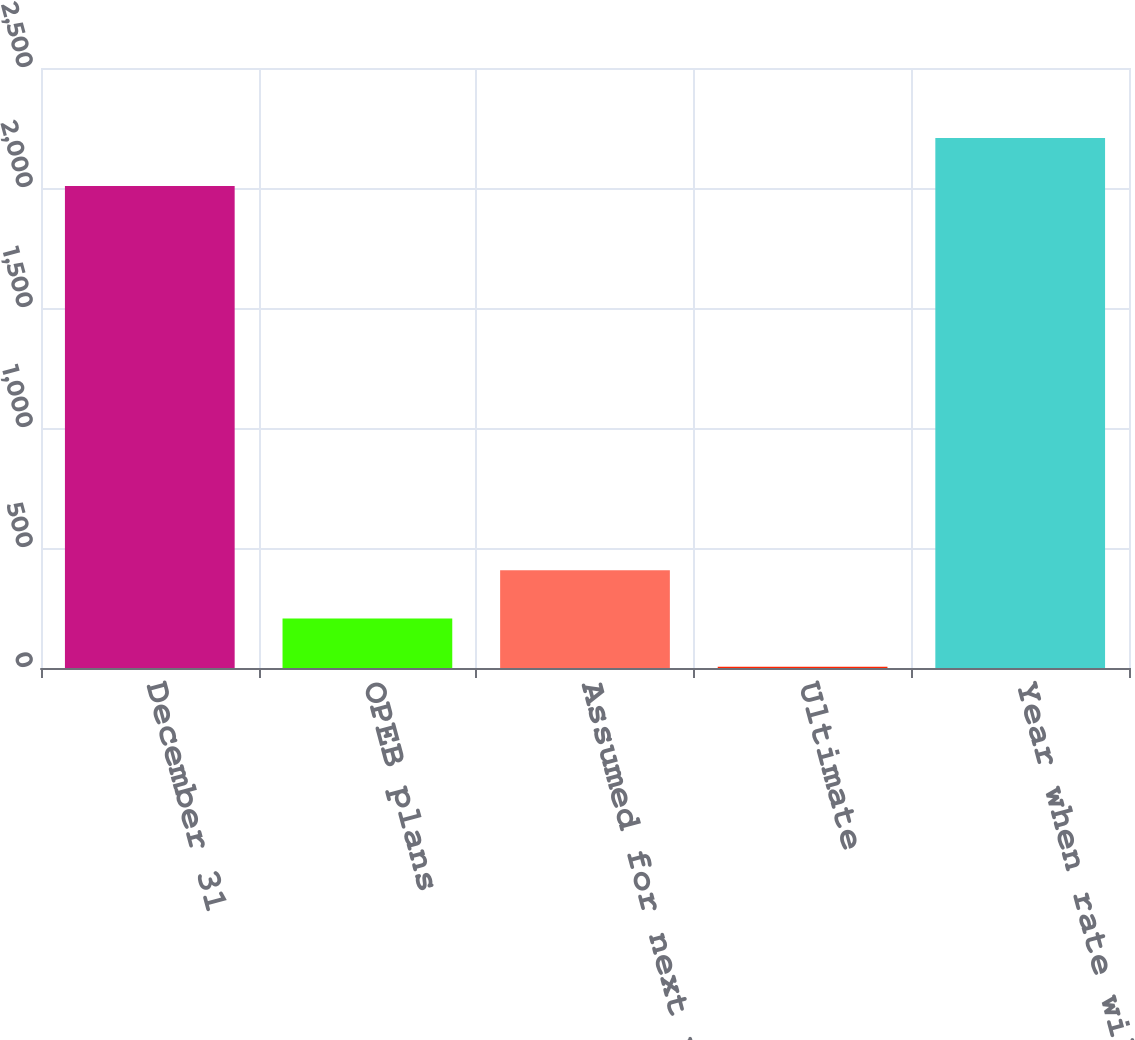Convert chart to OTSL. <chart><loc_0><loc_0><loc_500><loc_500><bar_chart><fcel>December 31<fcel>OPEB plans<fcel>Assumed for next year<fcel>Ultimate<fcel>Year when rate will reach<nl><fcel>2008<fcel>206.15<fcel>406.8<fcel>5.5<fcel>2208.65<nl></chart> 